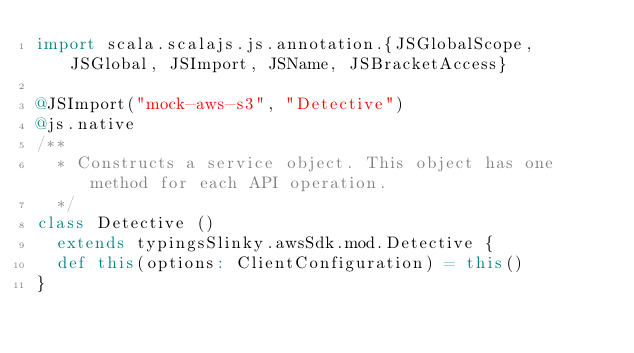Convert code to text. <code><loc_0><loc_0><loc_500><loc_500><_Scala_>import scala.scalajs.js.annotation.{JSGlobalScope, JSGlobal, JSImport, JSName, JSBracketAccess}

@JSImport("mock-aws-s3", "Detective")
@js.native
/**
  * Constructs a service object. This object has one method for each API operation.
  */
class Detective ()
  extends typingsSlinky.awsSdk.mod.Detective {
  def this(options: ClientConfiguration) = this()
}
</code> 